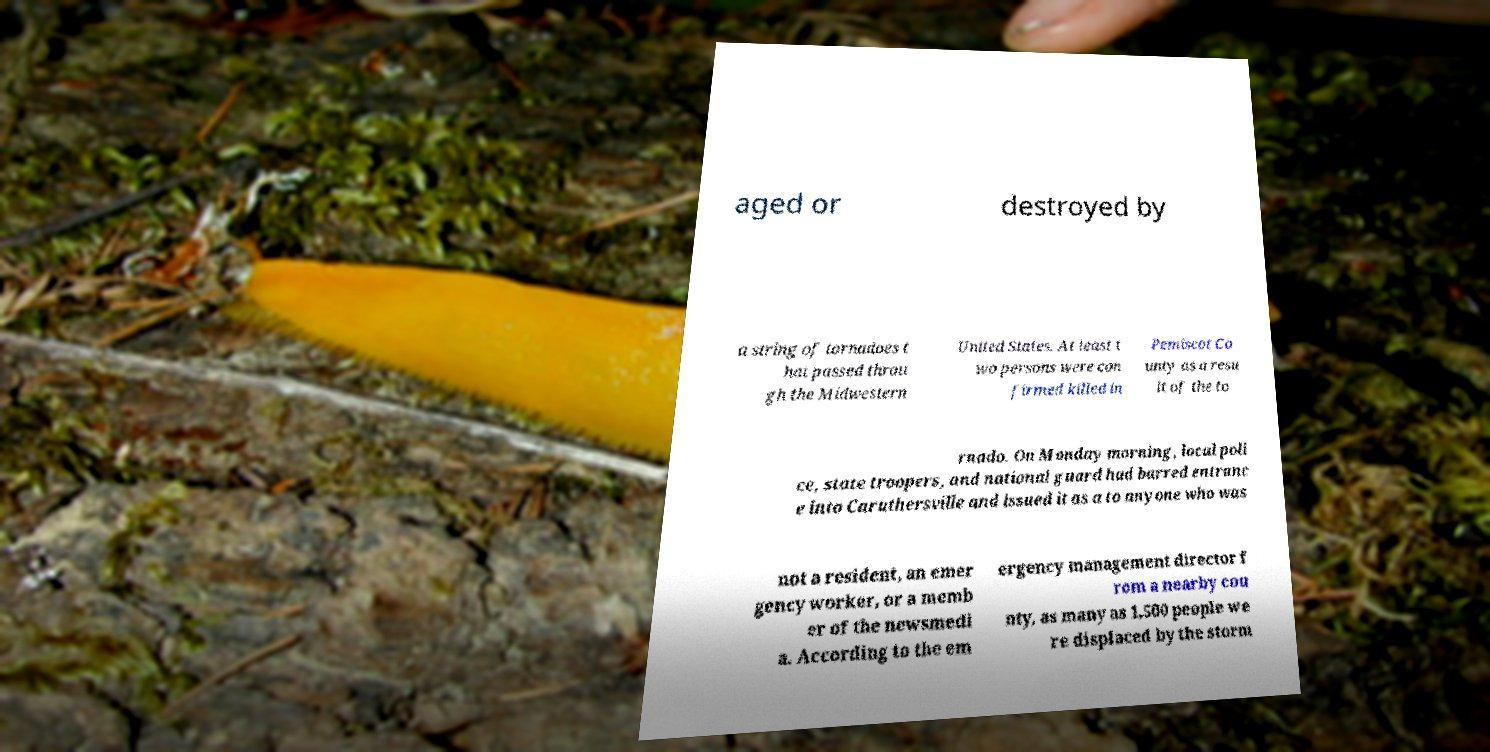For documentation purposes, I need the text within this image transcribed. Could you provide that? aged or destroyed by a string of tornadoes t hat passed throu gh the Midwestern United States. At least t wo persons were con firmed killed in Pemiscot Co unty as a resu lt of the to rnado. On Monday morning, local poli ce, state troopers, and national guard had barred entranc e into Caruthersville and issued it as a to anyone who was not a resident, an emer gency worker, or a memb er of the newsmedi a. According to the em ergency management director f rom a nearby cou nty, as many as 1,500 people we re displaced by the storm 